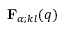<formula> <loc_0><loc_0><loc_500><loc_500>{ F } _ { \alpha ; k l } ( q )</formula> 